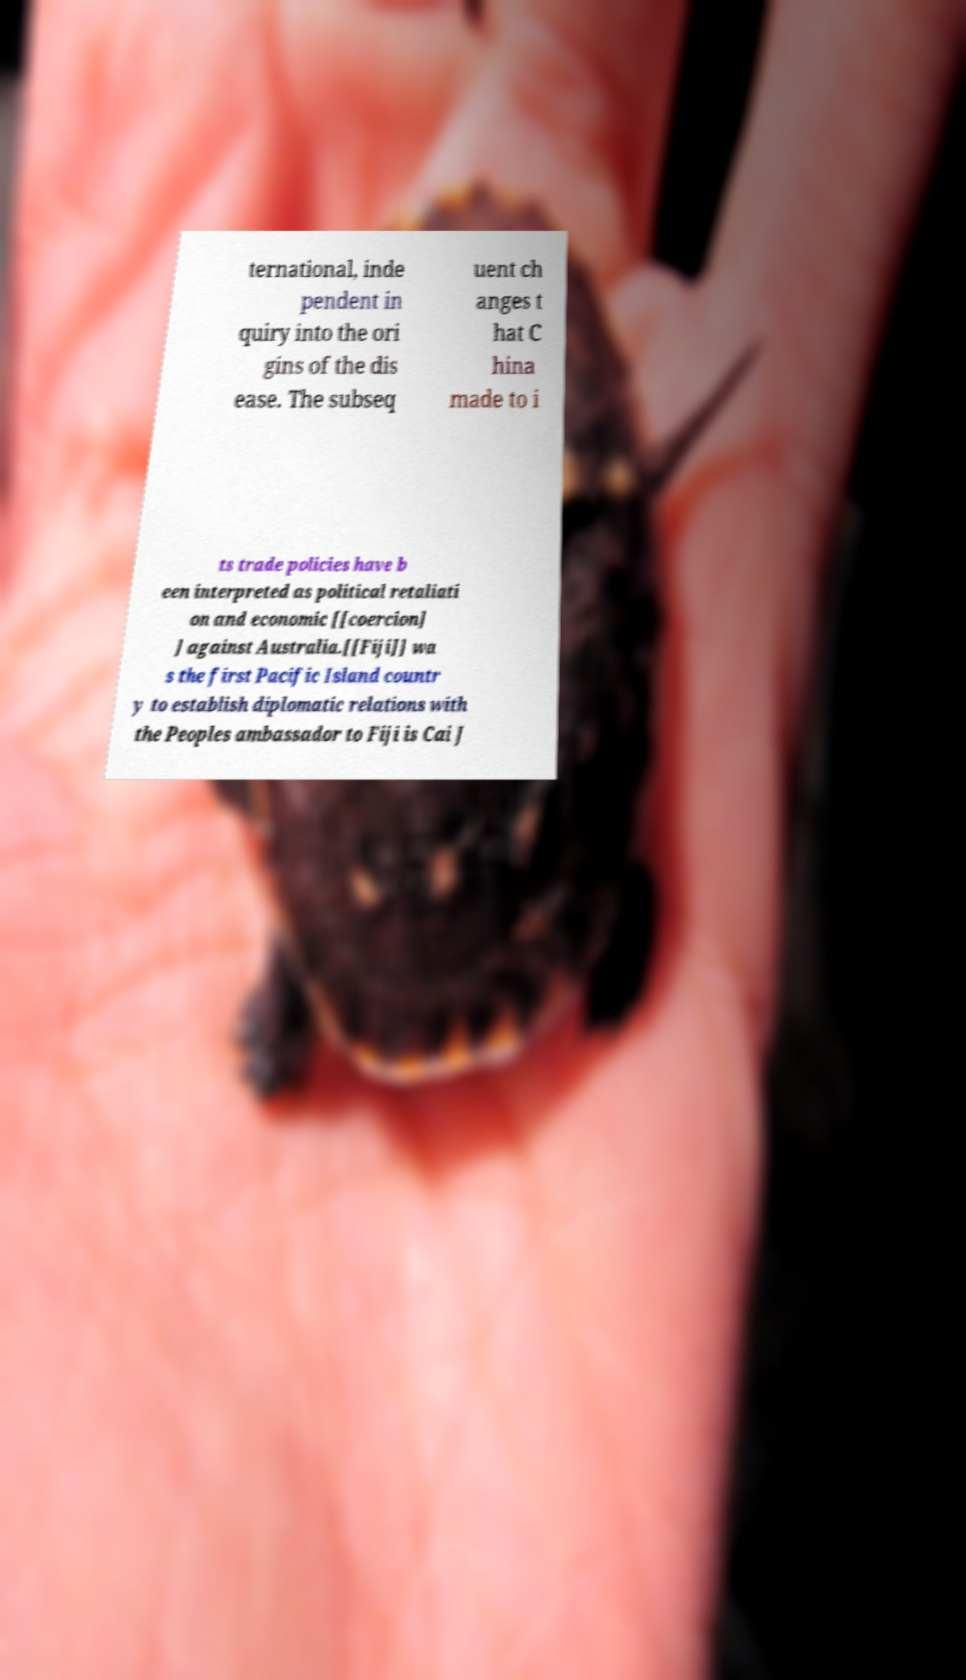I need the written content from this picture converted into text. Can you do that? ternational, inde pendent in quiry into the ori gins of the dis ease. The subseq uent ch anges t hat C hina made to i ts trade policies have b een interpreted as political retaliati on and economic [[coercion] ] against Australia.[[Fiji]] wa s the first Pacific Island countr y to establish diplomatic relations with the Peoples ambassador to Fiji is Cai J 